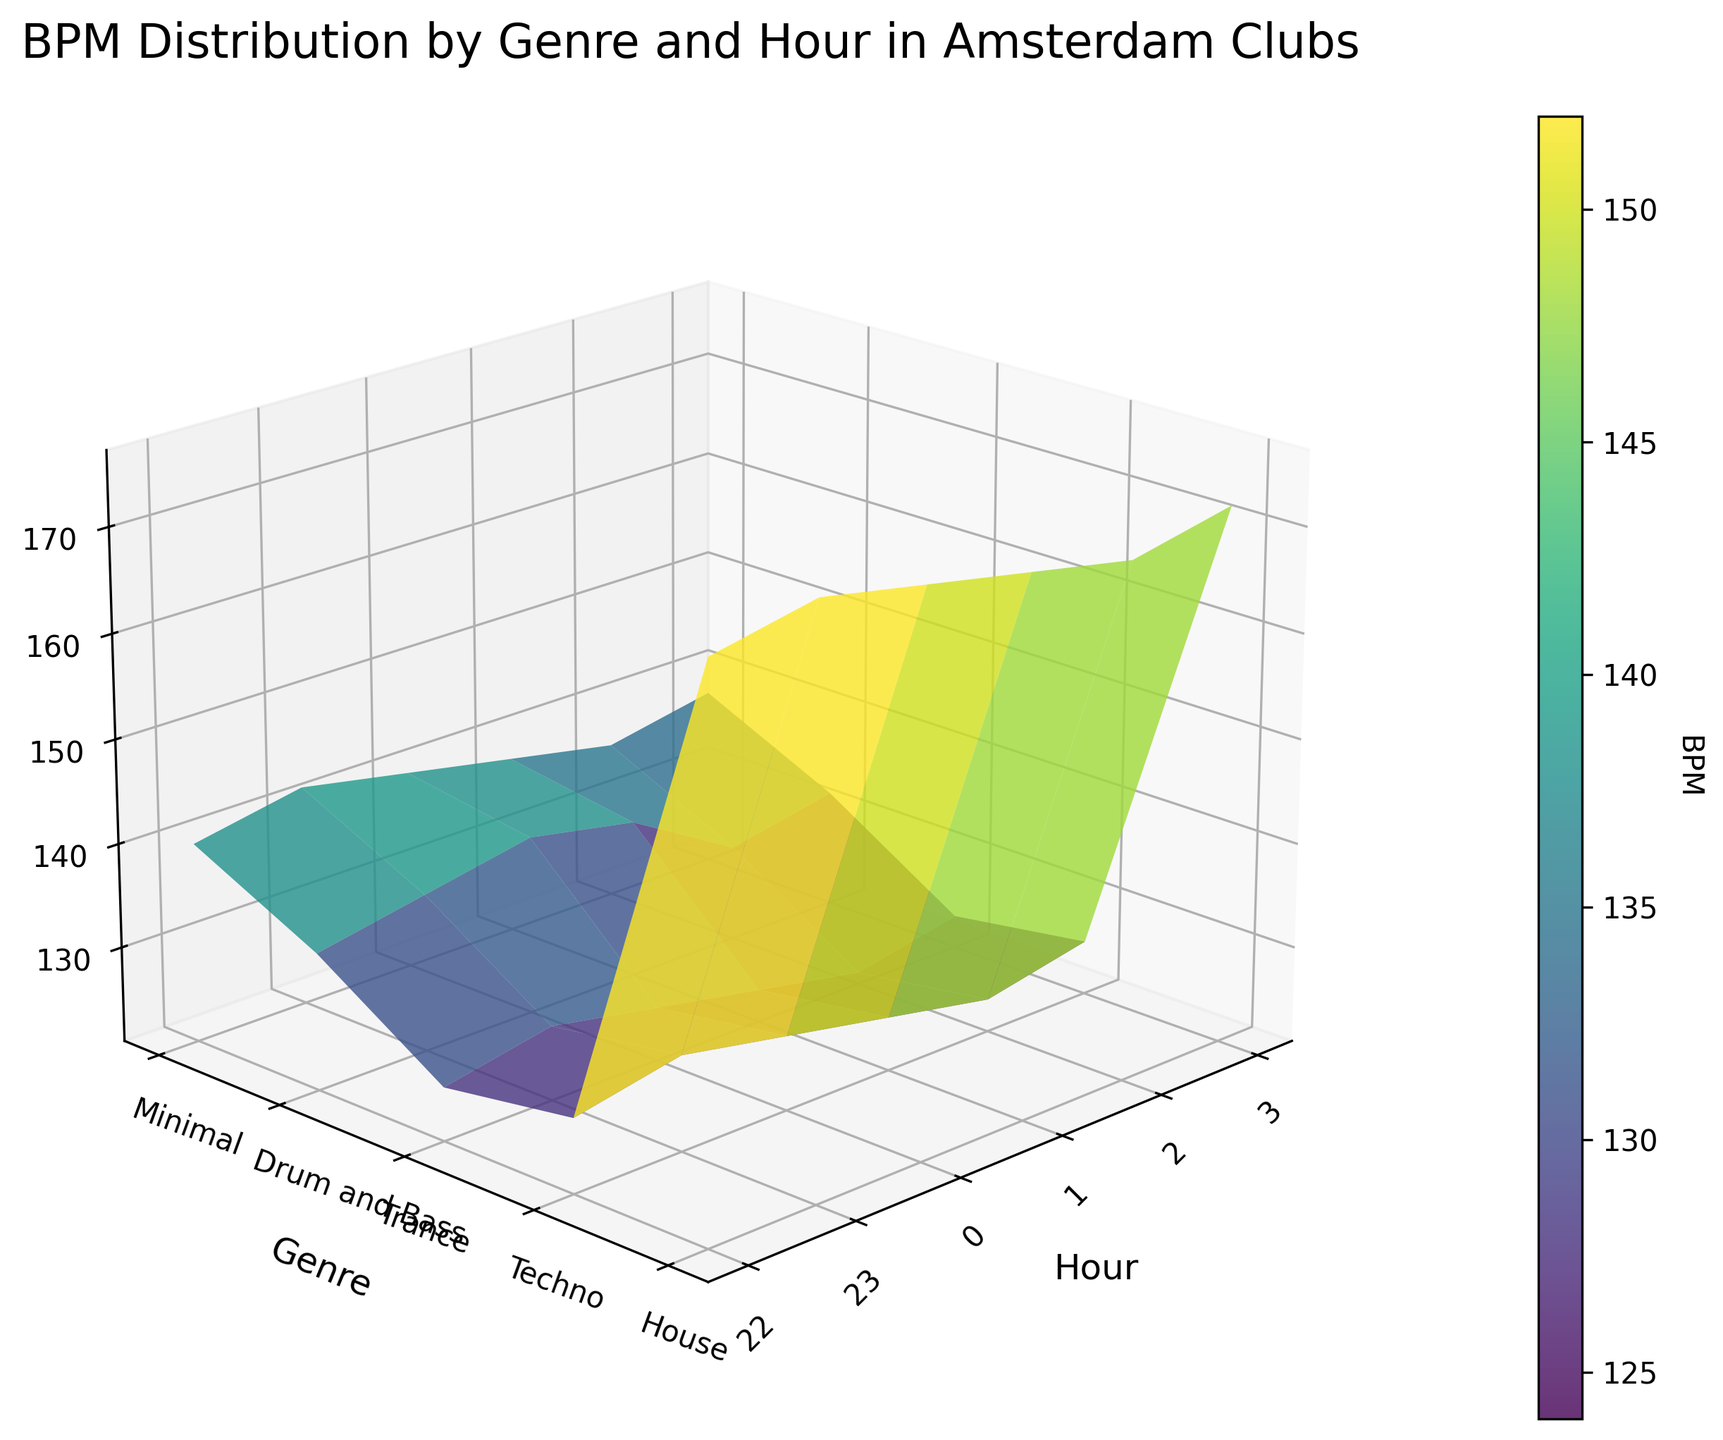What's the title of the plot? The title of the plot can be found at the top of the figure in large, bold text. Looking at that area, the title is clearly displayed.
Answer: BPM Distribution by Genre and Hour in Amsterdam Clubs What's the highest BPM value and at what hour does it occur? By examining the 3D surface plot and observing the peak on the Z-axis (BPM), the highest value is around 176 BPM. Tracing this peak down to the X-axis shows it occurs at hour 1.
Answer: 176 BPM at hour 1 During which hour do all genres have the lowest BPM values on average? To find this, observe the Z-axis (BPM) values across all genres per hour. Hour 22 shows the lowest BPM values generally across genres. Computing an average for each hour confirms hour 22 has the lowest average BPM.
Answer: Hour 22 How does the BPM of House music change throughout the night? Focusing on the curve for House music, we can see that BPM starts at 124 at 22:00, increases gradually to 130 by 1:00, and then decreases back to 126 by 3:00.
Answer: Starts at 124, peaks at 130, and drops to 126 Which genre shows the most significant increase in BPM as the night progresses? By tracking BPM increases from the start (22:00) to the end (3:00) for each genre, Drum and Bass shows a notable rise from 170 to 176 at 1:00 but stabilizes back to 172. However, Techno shows a consistent increase from 130 to 138, making it overall more significant.
Answer: Techno What is the BPM of Drum and Bass music at midnight (0:00)? Locate the Drum and Bass genre on the Y-axis and move vertically to hour 0 (midnight) on the X-axis. The intersecting Z-axis (BPM) value is 174 BPM.
Answer: 174 BPM Between Minimal and House, which genre has fluctuates less throughout the night? Observe the Z-axis changes for each hour concerning Minimal and House. Minimal ranges from 122 to 128, a 6 BPM range, whereas House varies from 124 to 130, a 6 BPM range. Both fluctuate equally.
Answer: Both fluctuate equally (6 BPM) Which genre peaks the latest in the night? Compare peaks of BPM values across genres by observing which genre has the highest BPM at the latest hour. Drum and Bass peaks at 1:00, while Trance and Techno at 2:00, where the highest BPM is more towards the end.
Answer: Trance and Techno 